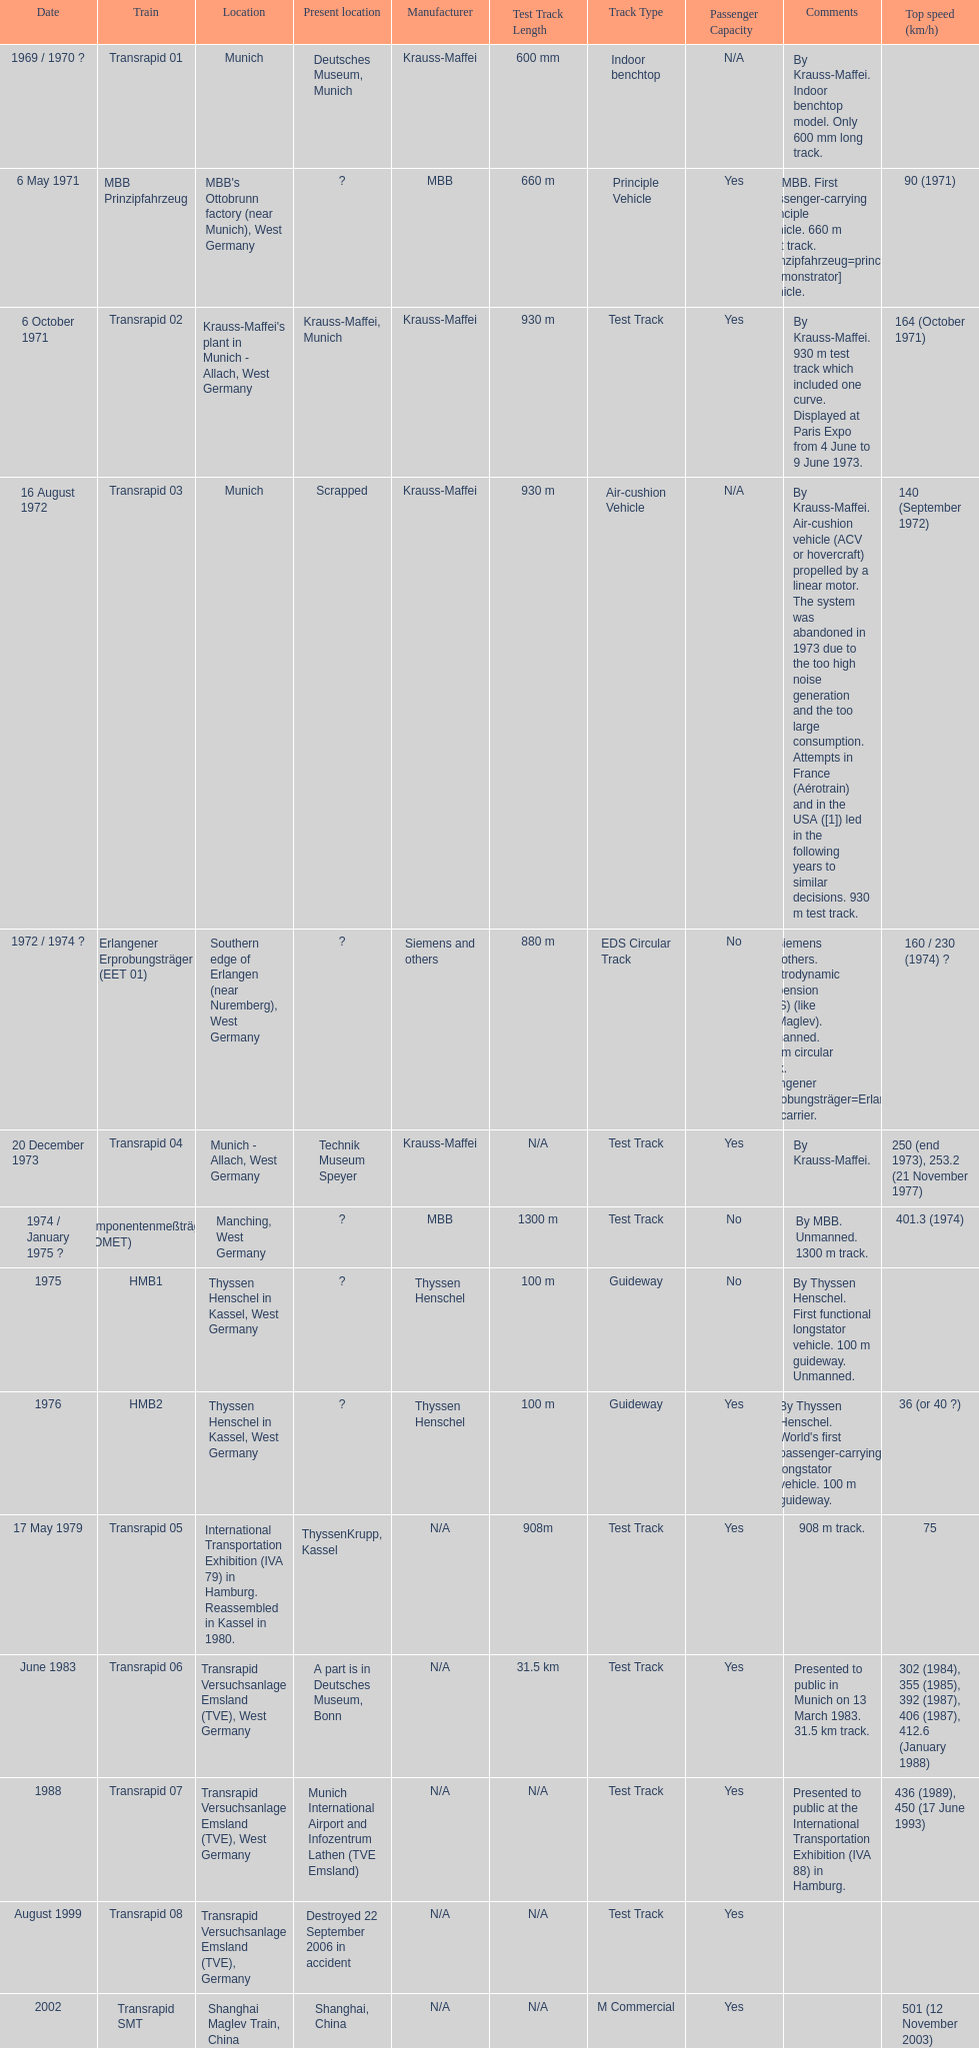What is the quantity of trains that were either scrapped or ruined? 2. 